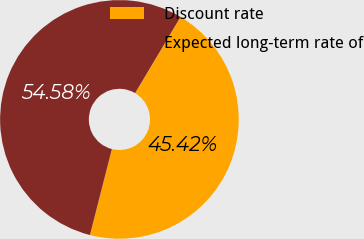<chart> <loc_0><loc_0><loc_500><loc_500><pie_chart><fcel>Discount rate<fcel>Expected long-term rate of<nl><fcel>45.42%<fcel>54.58%<nl></chart> 